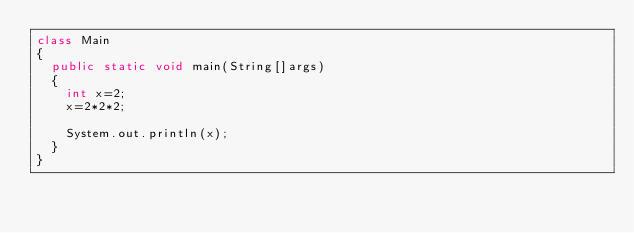Convert code to text. <code><loc_0><loc_0><loc_500><loc_500><_Java_>class Main
{
	public static void main(String[]args)
	{
		int x=2;
		x=2*2*2;
 
		System.out.println(x);
	}
}</code> 